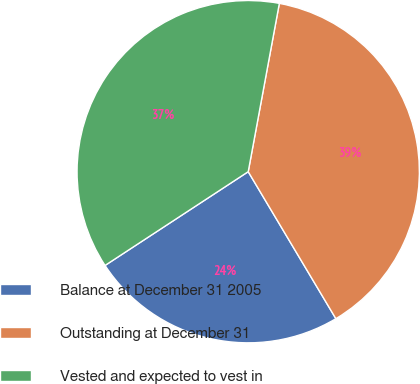Convert chart to OTSL. <chart><loc_0><loc_0><loc_500><loc_500><pie_chart><fcel>Balance at December 31 2005<fcel>Outstanding at December 31<fcel>Vested and expected to vest in<nl><fcel>24.33%<fcel>38.53%<fcel>37.14%<nl></chart> 